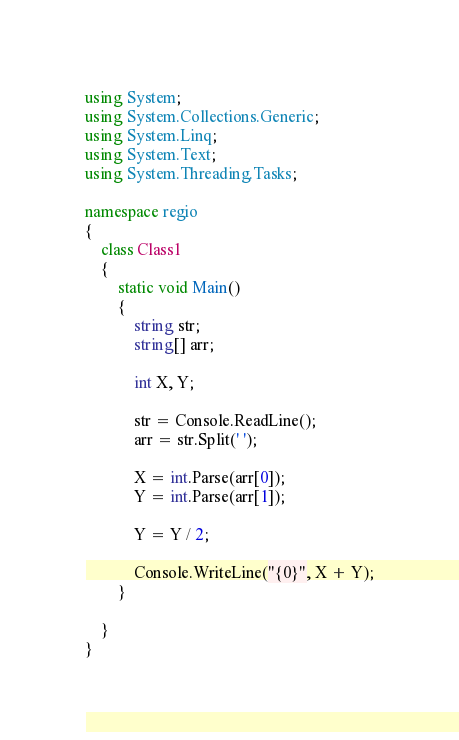<code> <loc_0><loc_0><loc_500><loc_500><_C#_>using System;
using System.Collections.Generic;
using System.Linq;
using System.Text;
using System.Threading.Tasks;

namespace regio
{
    class Class1
    {
        static void Main()
        {
            string str;
            string[] arr;

            int X, Y;

            str = Console.ReadLine();
            arr = str.Split(' ');

            X = int.Parse(arr[0]);
            Y = int.Parse(arr[1]);

            Y = Y / 2;

            Console.WriteLine("{0}", X + Y);
        }
        
    }
}
</code> 